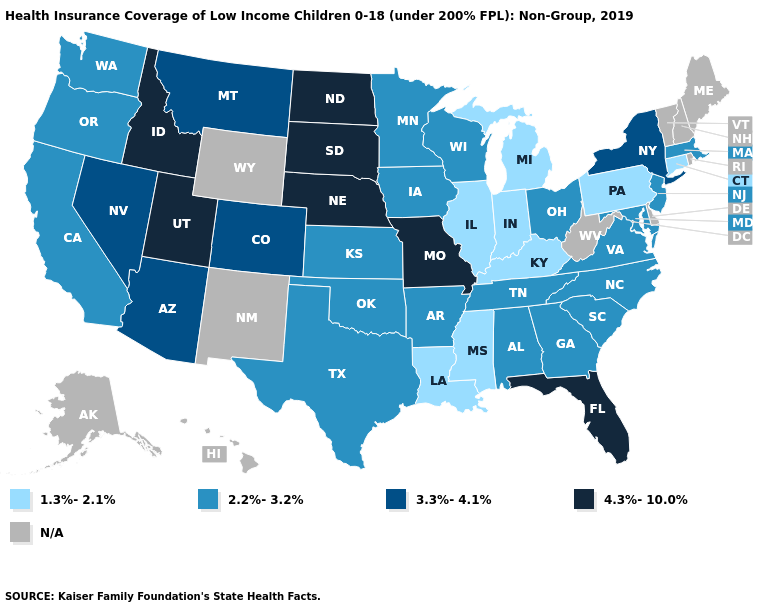Which states have the lowest value in the USA?
Give a very brief answer. Connecticut, Illinois, Indiana, Kentucky, Louisiana, Michigan, Mississippi, Pennsylvania. Name the states that have a value in the range 3.3%-4.1%?
Give a very brief answer. Arizona, Colorado, Montana, Nevada, New York. Does the map have missing data?
Concise answer only. Yes. Among the states that border Nevada , which have the lowest value?
Quick response, please. California, Oregon. How many symbols are there in the legend?
Quick response, please. 5. What is the value of Hawaii?
Concise answer only. N/A. Does the map have missing data?
Quick response, please. Yes. Among the states that border Kentucky , does Virginia have the highest value?
Quick response, please. No. What is the highest value in the USA?
Quick response, please. 4.3%-10.0%. Name the states that have a value in the range N/A?
Be succinct. Alaska, Delaware, Hawaii, Maine, New Hampshire, New Mexico, Rhode Island, Vermont, West Virginia, Wyoming. Does the map have missing data?
Quick response, please. Yes. What is the highest value in states that border New Jersey?
Answer briefly. 3.3%-4.1%. 